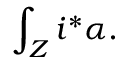<formula> <loc_0><loc_0><loc_500><loc_500>\int _ { Z } i ^ { * } \alpha .</formula> 